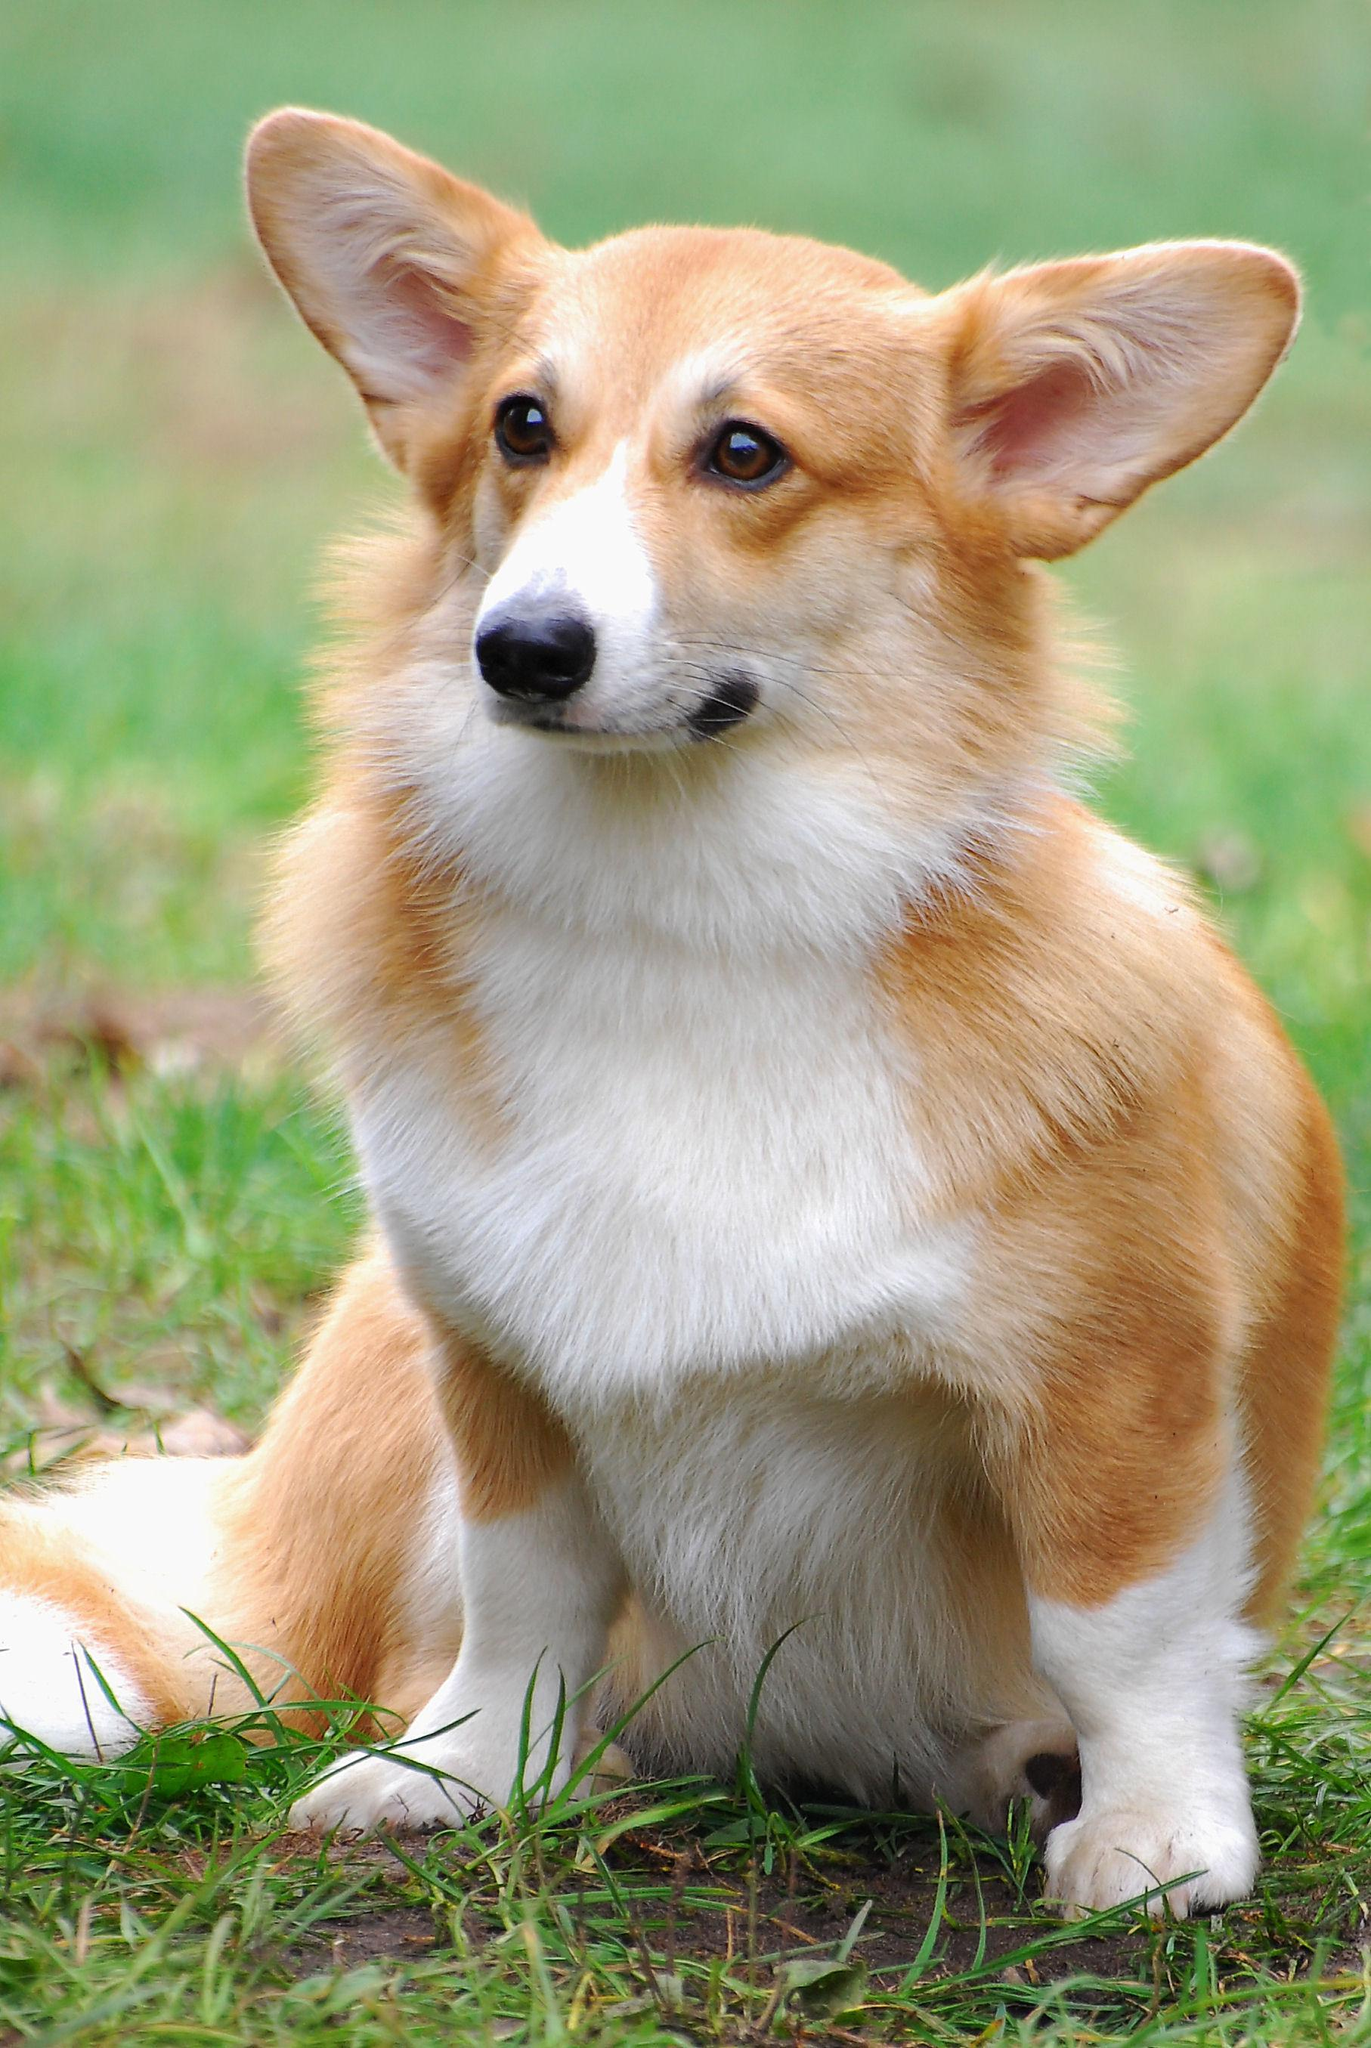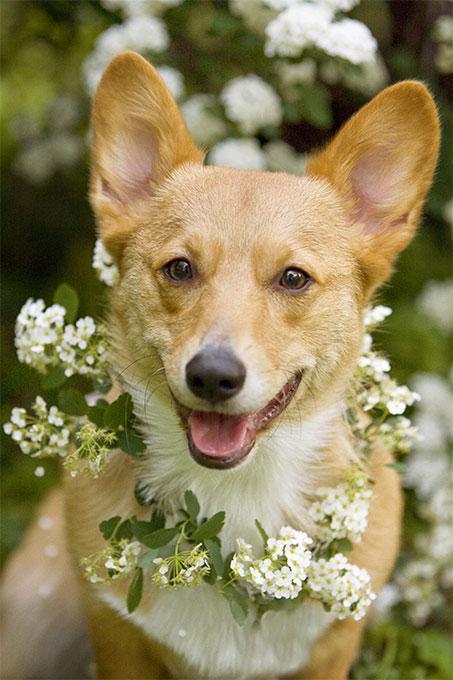The first image is the image on the left, the second image is the image on the right. Considering the images on both sides, is "The dog in the image on the right is standing on all fours in the grass." valid? Answer yes or no. No. The first image is the image on the left, the second image is the image on the right. For the images displayed, is the sentence "An image shows one dog with upright ears posed with white flowers." factually correct? Answer yes or no. Yes. 